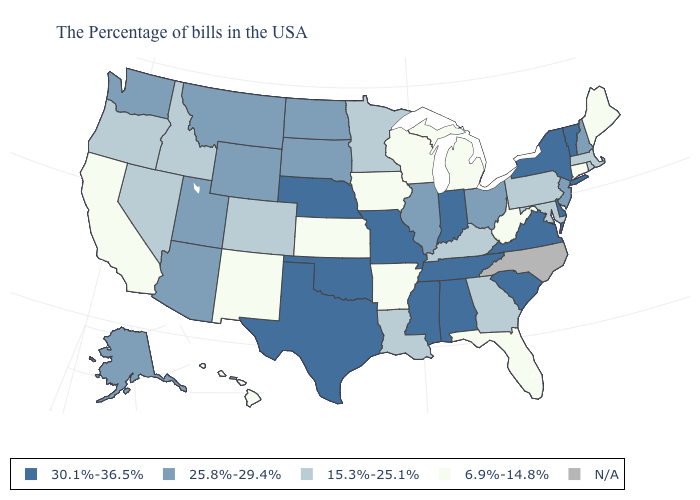Name the states that have a value in the range N/A?
Quick response, please. North Carolina. What is the value of Maryland?
Concise answer only. 15.3%-25.1%. Name the states that have a value in the range 15.3%-25.1%?
Keep it brief. Massachusetts, Rhode Island, Maryland, Pennsylvania, Georgia, Kentucky, Louisiana, Minnesota, Colorado, Idaho, Nevada, Oregon. Does the first symbol in the legend represent the smallest category?
Short answer required. No. What is the highest value in the MidWest ?
Be succinct. 30.1%-36.5%. Name the states that have a value in the range 30.1%-36.5%?
Short answer required. Vermont, New York, Delaware, Virginia, South Carolina, Indiana, Alabama, Tennessee, Mississippi, Missouri, Nebraska, Oklahoma, Texas. Name the states that have a value in the range 25.8%-29.4%?
Answer briefly. New Hampshire, New Jersey, Ohio, Illinois, South Dakota, North Dakota, Wyoming, Utah, Montana, Arizona, Washington, Alaska. How many symbols are there in the legend?
Give a very brief answer. 5. Among the states that border North Carolina , does Georgia have the highest value?
Concise answer only. No. Name the states that have a value in the range 15.3%-25.1%?
Keep it brief. Massachusetts, Rhode Island, Maryland, Pennsylvania, Georgia, Kentucky, Louisiana, Minnesota, Colorado, Idaho, Nevada, Oregon. Name the states that have a value in the range 15.3%-25.1%?
Write a very short answer. Massachusetts, Rhode Island, Maryland, Pennsylvania, Georgia, Kentucky, Louisiana, Minnesota, Colorado, Idaho, Nevada, Oregon. What is the value of Alaska?
Concise answer only. 25.8%-29.4%. What is the value of New Mexico?
Write a very short answer. 6.9%-14.8%. Which states have the highest value in the USA?
Keep it brief. Vermont, New York, Delaware, Virginia, South Carolina, Indiana, Alabama, Tennessee, Mississippi, Missouri, Nebraska, Oklahoma, Texas. What is the value of New Hampshire?
Answer briefly. 25.8%-29.4%. 